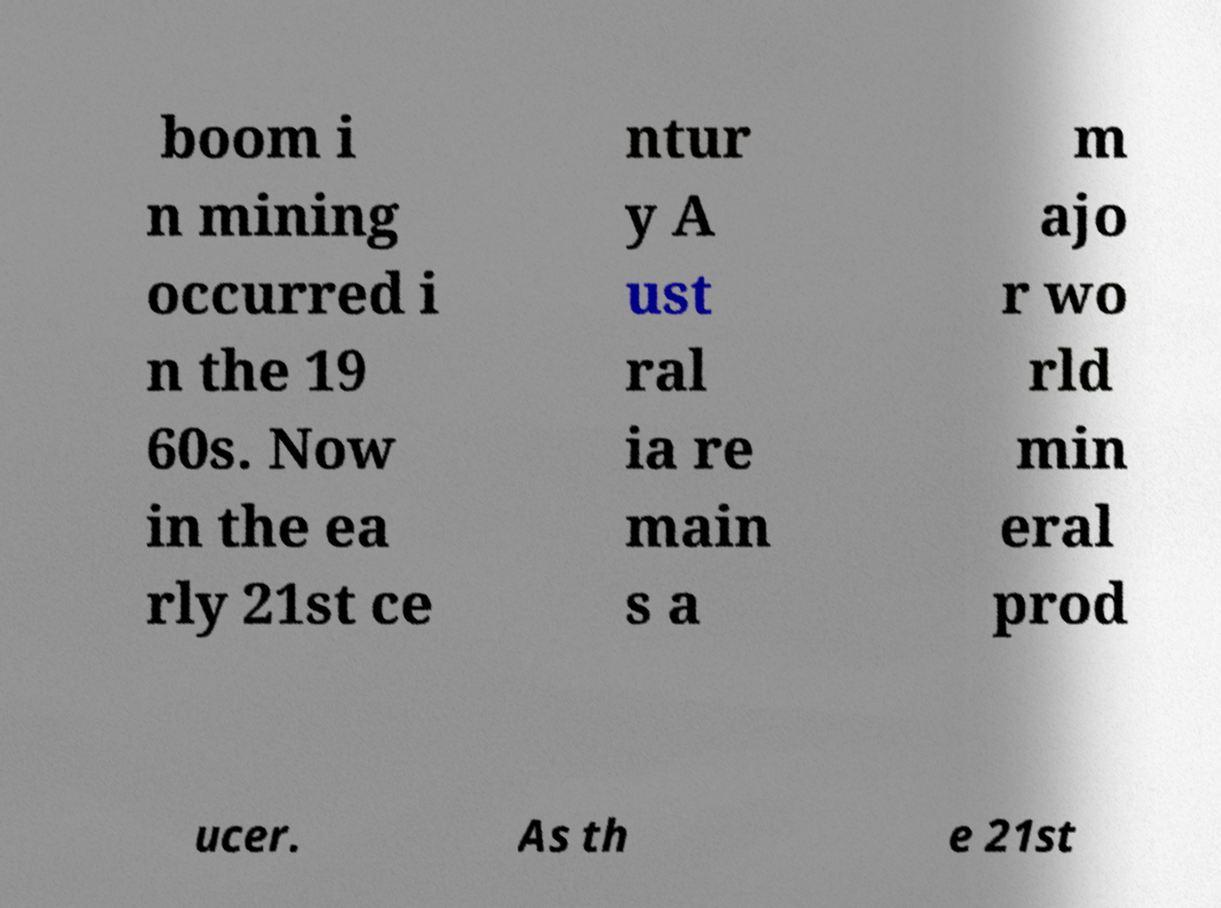For documentation purposes, I need the text within this image transcribed. Could you provide that? boom i n mining occurred i n the 19 60s. Now in the ea rly 21st ce ntur y A ust ral ia re main s a m ajo r wo rld min eral prod ucer. As th e 21st 